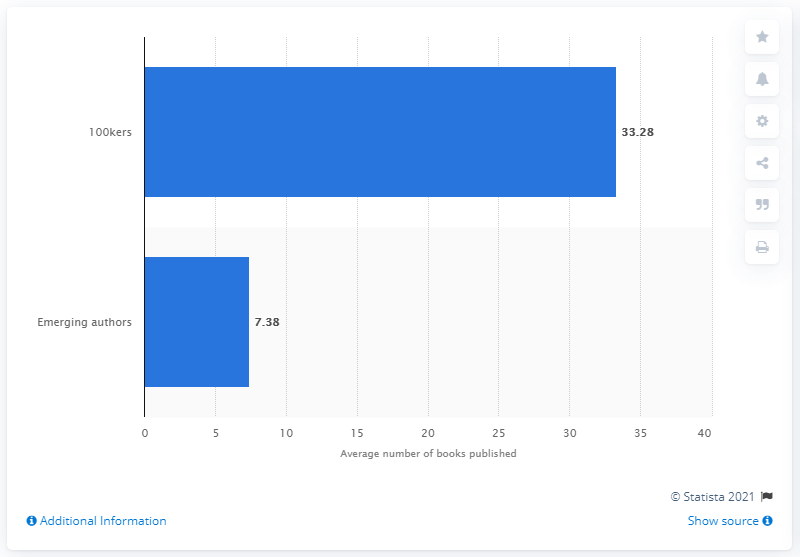Identify some key points in this picture. In 2017, the average number of books published by authors earning over 100 thousand dollars in income was 33.28. In 2017, the average number of books published by authors earning over $100,000 in income was 33.28 books. 